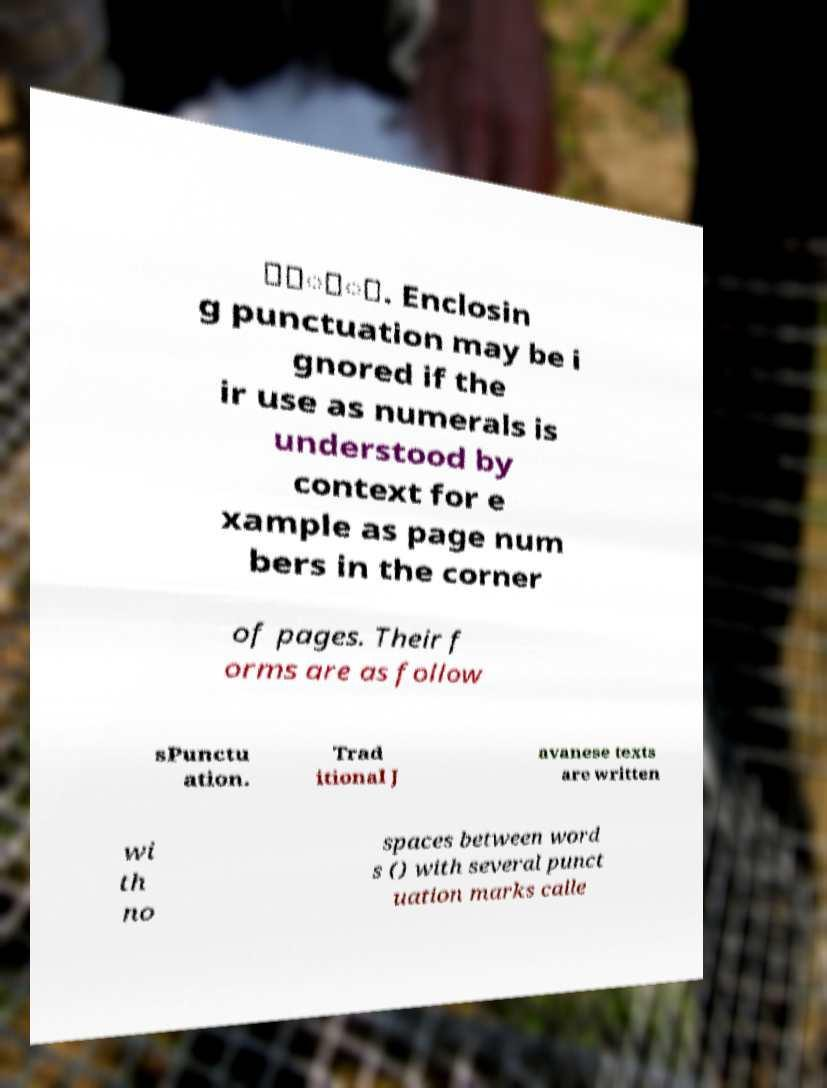Can you read and provide the text displayed in the image?This photo seems to have some interesting text. Can you extract and type it out for me? ꧈꧈ꦸꦶ. Enclosin g punctuation may be i gnored if the ir use as numerals is understood by context for e xample as page num bers in the corner of pages. Their f orms are as follow sPunctu ation. Trad itional J avanese texts are written wi th no spaces between word s () with several punct uation marks calle 